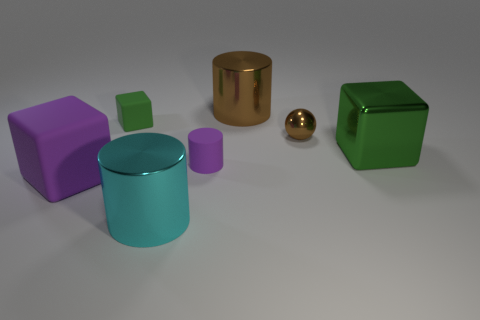Add 2 small blue things. How many objects exist? 9 Subtract all cylinders. How many objects are left? 4 Add 5 small metal spheres. How many small metal spheres are left? 6 Add 1 cylinders. How many cylinders exist? 4 Subtract 1 purple blocks. How many objects are left? 6 Subtract all tiny green rubber cylinders. Subtract all green things. How many objects are left? 5 